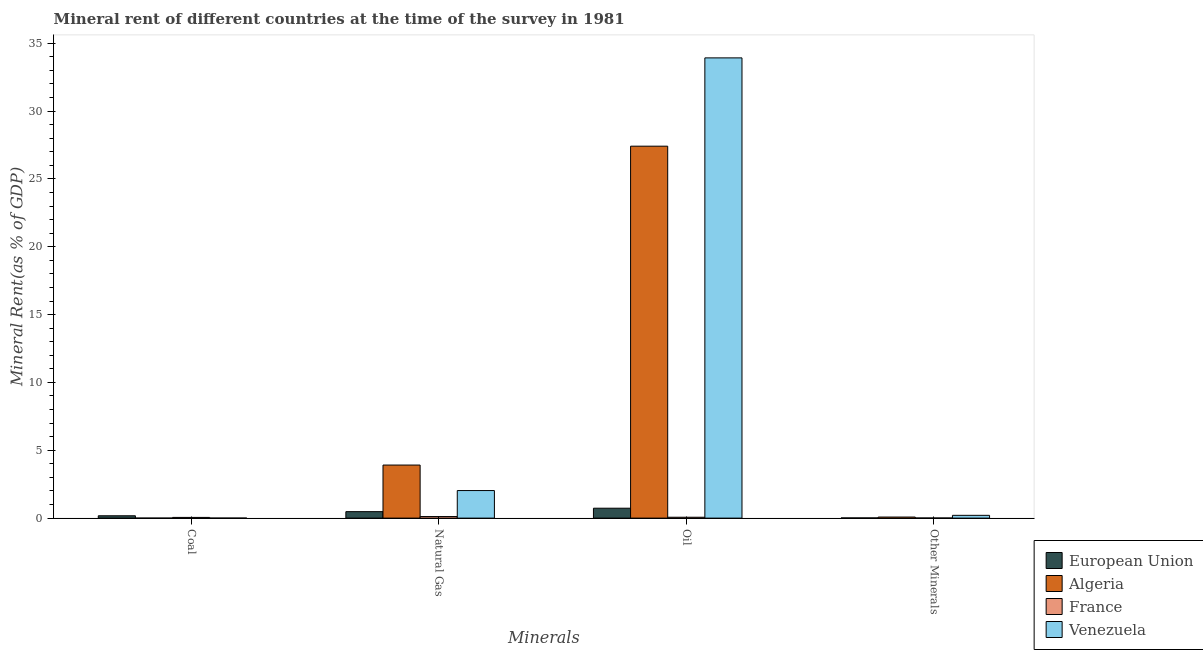How many groups of bars are there?
Ensure brevity in your answer.  4. How many bars are there on the 4th tick from the left?
Provide a succinct answer. 4. What is the label of the 1st group of bars from the left?
Keep it short and to the point. Coal. What is the  rent of other minerals in France?
Your answer should be compact. 0.01. Across all countries, what is the maximum coal rent?
Provide a succinct answer. 0.17. Across all countries, what is the minimum coal rent?
Make the answer very short. 0. In which country was the coal rent maximum?
Your response must be concise. European Union. What is the total coal rent in the graph?
Provide a succinct answer. 0.23. What is the difference between the  rent of other minerals in European Union and that in France?
Your answer should be compact. 0.01. What is the difference between the oil rent in France and the natural gas rent in Venezuela?
Your answer should be very brief. -1.97. What is the average coal rent per country?
Offer a very short reply. 0.06. What is the difference between the oil rent and  rent of other minerals in France?
Provide a short and direct response. 0.06. In how many countries, is the coal rent greater than 3 %?
Keep it short and to the point. 0. What is the ratio of the oil rent in France to that in Algeria?
Your answer should be very brief. 0. What is the difference between the highest and the second highest  rent of other minerals?
Keep it short and to the point. 0.13. What is the difference between the highest and the lowest  rent of other minerals?
Provide a succinct answer. 0.2. Is the sum of the oil rent in France and European Union greater than the maximum natural gas rent across all countries?
Keep it short and to the point. No. What does the 3rd bar from the left in Natural Gas represents?
Give a very brief answer. France. What does the 3rd bar from the right in Natural Gas represents?
Keep it short and to the point. Algeria. Is it the case that in every country, the sum of the coal rent and natural gas rent is greater than the oil rent?
Your answer should be compact. No. How many bars are there?
Your answer should be very brief. 16. Are the values on the major ticks of Y-axis written in scientific E-notation?
Give a very brief answer. No. Does the graph contain grids?
Provide a succinct answer. No. What is the title of the graph?
Make the answer very short. Mineral rent of different countries at the time of the survey in 1981. What is the label or title of the X-axis?
Offer a terse response. Minerals. What is the label or title of the Y-axis?
Offer a terse response. Mineral Rent(as % of GDP). What is the Mineral Rent(as % of GDP) in European Union in Coal?
Your answer should be very brief. 0.17. What is the Mineral Rent(as % of GDP) of Algeria in Coal?
Provide a succinct answer. 0. What is the Mineral Rent(as % of GDP) in France in Coal?
Give a very brief answer. 0.05. What is the Mineral Rent(as % of GDP) of Venezuela in Coal?
Provide a short and direct response. 0. What is the Mineral Rent(as % of GDP) in European Union in Natural Gas?
Give a very brief answer. 0.48. What is the Mineral Rent(as % of GDP) of Algeria in Natural Gas?
Keep it short and to the point. 3.91. What is the Mineral Rent(as % of GDP) in France in Natural Gas?
Keep it short and to the point. 0.12. What is the Mineral Rent(as % of GDP) in Venezuela in Natural Gas?
Your answer should be compact. 2.03. What is the Mineral Rent(as % of GDP) in European Union in Oil?
Your answer should be compact. 0.73. What is the Mineral Rent(as % of GDP) in Algeria in Oil?
Offer a terse response. 27.41. What is the Mineral Rent(as % of GDP) of France in Oil?
Provide a short and direct response. 0.06. What is the Mineral Rent(as % of GDP) in Venezuela in Oil?
Keep it short and to the point. 33.92. What is the Mineral Rent(as % of GDP) in European Union in Other Minerals?
Keep it short and to the point. 0.01. What is the Mineral Rent(as % of GDP) in Algeria in Other Minerals?
Offer a terse response. 0.08. What is the Mineral Rent(as % of GDP) in France in Other Minerals?
Ensure brevity in your answer.  0.01. What is the Mineral Rent(as % of GDP) in Venezuela in Other Minerals?
Provide a short and direct response. 0.2. Across all Minerals, what is the maximum Mineral Rent(as % of GDP) of European Union?
Give a very brief answer. 0.73. Across all Minerals, what is the maximum Mineral Rent(as % of GDP) of Algeria?
Make the answer very short. 27.41. Across all Minerals, what is the maximum Mineral Rent(as % of GDP) of France?
Offer a terse response. 0.12. Across all Minerals, what is the maximum Mineral Rent(as % of GDP) in Venezuela?
Keep it short and to the point. 33.92. Across all Minerals, what is the minimum Mineral Rent(as % of GDP) of European Union?
Your answer should be compact. 0.01. Across all Minerals, what is the minimum Mineral Rent(as % of GDP) of Algeria?
Ensure brevity in your answer.  0. Across all Minerals, what is the minimum Mineral Rent(as % of GDP) of France?
Offer a very short reply. 0.01. Across all Minerals, what is the minimum Mineral Rent(as % of GDP) in Venezuela?
Your answer should be very brief. 0. What is the total Mineral Rent(as % of GDP) in European Union in the graph?
Your answer should be very brief. 1.39. What is the total Mineral Rent(as % of GDP) of Algeria in the graph?
Provide a short and direct response. 31.4. What is the total Mineral Rent(as % of GDP) in France in the graph?
Your answer should be very brief. 0.24. What is the total Mineral Rent(as % of GDP) in Venezuela in the graph?
Ensure brevity in your answer.  36.16. What is the difference between the Mineral Rent(as % of GDP) of European Union in Coal and that in Natural Gas?
Your response must be concise. -0.3. What is the difference between the Mineral Rent(as % of GDP) of Algeria in Coal and that in Natural Gas?
Offer a very short reply. -3.91. What is the difference between the Mineral Rent(as % of GDP) of France in Coal and that in Natural Gas?
Provide a short and direct response. -0.06. What is the difference between the Mineral Rent(as % of GDP) in Venezuela in Coal and that in Natural Gas?
Your answer should be compact. -2.03. What is the difference between the Mineral Rent(as % of GDP) of European Union in Coal and that in Oil?
Keep it short and to the point. -0.56. What is the difference between the Mineral Rent(as % of GDP) of Algeria in Coal and that in Oil?
Keep it short and to the point. -27.41. What is the difference between the Mineral Rent(as % of GDP) of France in Coal and that in Oil?
Ensure brevity in your answer.  -0.01. What is the difference between the Mineral Rent(as % of GDP) in Venezuela in Coal and that in Oil?
Provide a succinct answer. -33.92. What is the difference between the Mineral Rent(as % of GDP) in European Union in Coal and that in Other Minerals?
Make the answer very short. 0.16. What is the difference between the Mineral Rent(as % of GDP) in Algeria in Coal and that in Other Minerals?
Your answer should be compact. -0.08. What is the difference between the Mineral Rent(as % of GDP) of France in Coal and that in Other Minerals?
Your response must be concise. 0.04. What is the difference between the Mineral Rent(as % of GDP) of Venezuela in Coal and that in Other Minerals?
Offer a terse response. -0.2. What is the difference between the Mineral Rent(as % of GDP) of European Union in Natural Gas and that in Oil?
Your answer should be very brief. -0.25. What is the difference between the Mineral Rent(as % of GDP) of Algeria in Natural Gas and that in Oil?
Your response must be concise. -23.5. What is the difference between the Mineral Rent(as % of GDP) of France in Natural Gas and that in Oil?
Offer a very short reply. 0.05. What is the difference between the Mineral Rent(as % of GDP) in Venezuela in Natural Gas and that in Oil?
Offer a terse response. -31.89. What is the difference between the Mineral Rent(as % of GDP) of European Union in Natural Gas and that in Other Minerals?
Your response must be concise. 0.46. What is the difference between the Mineral Rent(as % of GDP) of Algeria in Natural Gas and that in Other Minerals?
Your answer should be compact. 3.83. What is the difference between the Mineral Rent(as % of GDP) of France in Natural Gas and that in Other Minerals?
Ensure brevity in your answer.  0.11. What is the difference between the Mineral Rent(as % of GDP) of Venezuela in Natural Gas and that in Other Minerals?
Keep it short and to the point. 1.83. What is the difference between the Mineral Rent(as % of GDP) of European Union in Oil and that in Other Minerals?
Your answer should be very brief. 0.72. What is the difference between the Mineral Rent(as % of GDP) in Algeria in Oil and that in Other Minerals?
Your response must be concise. 27.33. What is the difference between the Mineral Rent(as % of GDP) in France in Oil and that in Other Minerals?
Keep it short and to the point. 0.06. What is the difference between the Mineral Rent(as % of GDP) in Venezuela in Oil and that in Other Minerals?
Keep it short and to the point. 33.71. What is the difference between the Mineral Rent(as % of GDP) in European Union in Coal and the Mineral Rent(as % of GDP) in Algeria in Natural Gas?
Offer a very short reply. -3.74. What is the difference between the Mineral Rent(as % of GDP) in European Union in Coal and the Mineral Rent(as % of GDP) in France in Natural Gas?
Ensure brevity in your answer.  0.06. What is the difference between the Mineral Rent(as % of GDP) of European Union in Coal and the Mineral Rent(as % of GDP) of Venezuela in Natural Gas?
Provide a short and direct response. -1.86. What is the difference between the Mineral Rent(as % of GDP) in Algeria in Coal and the Mineral Rent(as % of GDP) in France in Natural Gas?
Provide a short and direct response. -0.12. What is the difference between the Mineral Rent(as % of GDP) in Algeria in Coal and the Mineral Rent(as % of GDP) in Venezuela in Natural Gas?
Make the answer very short. -2.03. What is the difference between the Mineral Rent(as % of GDP) in France in Coal and the Mineral Rent(as % of GDP) in Venezuela in Natural Gas?
Your response must be concise. -1.98. What is the difference between the Mineral Rent(as % of GDP) of European Union in Coal and the Mineral Rent(as % of GDP) of Algeria in Oil?
Your answer should be compact. -27.24. What is the difference between the Mineral Rent(as % of GDP) of European Union in Coal and the Mineral Rent(as % of GDP) of France in Oil?
Offer a terse response. 0.11. What is the difference between the Mineral Rent(as % of GDP) of European Union in Coal and the Mineral Rent(as % of GDP) of Venezuela in Oil?
Provide a short and direct response. -33.75. What is the difference between the Mineral Rent(as % of GDP) in Algeria in Coal and the Mineral Rent(as % of GDP) in France in Oil?
Give a very brief answer. -0.06. What is the difference between the Mineral Rent(as % of GDP) of Algeria in Coal and the Mineral Rent(as % of GDP) of Venezuela in Oil?
Make the answer very short. -33.92. What is the difference between the Mineral Rent(as % of GDP) in France in Coal and the Mineral Rent(as % of GDP) in Venezuela in Oil?
Offer a very short reply. -33.87. What is the difference between the Mineral Rent(as % of GDP) in European Union in Coal and the Mineral Rent(as % of GDP) in Algeria in Other Minerals?
Your answer should be very brief. 0.09. What is the difference between the Mineral Rent(as % of GDP) of European Union in Coal and the Mineral Rent(as % of GDP) of France in Other Minerals?
Ensure brevity in your answer.  0.16. What is the difference between the Mineral Rent(as % of GDP) of European Union in Coal and the Mineral Rent(as % of GDP) of Venezuela in Other Minerals?
Provide a short and direct response. -0.03. What is the difference between the Mineral Rent(as % of GDP) in Algeria in Coal and the Mineral Rent(as % of GDP) in France in Other Minerals?
Provide a short and direct response. -0.01. What is the difference between the Mineral Rent(as % of GDP) in Algeria in Coal and the Mineral Rent(as % of GDP) in Venezuela in Other Minerals?
Ensure brevity in your answer.  -0.2. What is the difference between the Mineral Rent(as % of GDP) of France in Coal and the Mineral Rent(as % of GDP) of Venezuela in Other Minerals?
Provide a succinct answer. -0.15. What is the difference between the Mineral Rent(as % of GDP) in European Union in Natural Gas and the Mineral Rent(as % of GDP) in Algeria in Oil?
Keep it short and to the point. -26.93. What is the difference between the Mineral Rent(as % of GDP) in European Union in Natural Gas and the Mineral Rent(as % of GDP) in France in Oil?
Your answer should be very brief. 0.41. What is the difference between the Mineral Rent(as % of GDP) in European Union in Natural Gas and the Mineral Rent(as % of GDP) in Venezuela in Oil?
Your response must be concise. -33.44. What is the difference between the Mineral Rent(as % of GDP) in Algeria in Natural Gas and the Mineral Rent(as % of GDP) in France in Oil?
Your answer should be very brief. 3.85. What is the difference between the Mineral Rent(as % of GDP) in Algeria in Natural Gas and the Mineral Rent(as % of GDP) in Venezuela in Oil?
Provide a short and direct response. -30.01. What is the difference between the Mineral Rent(as % of GDP) in France in Natural Gas and the Mineral Rent(as % of GDP) in Venezuela in Oil?
Provide a succinct answer. -33.8. What is the difference between the Mineral Rent(as % of GDP) in European Union in Natural Gas and the Mineral Rent(as % of GDP) in Algeria in Other Minerals?
Provide a succinct answer. 0.4. What is the difference between the Mineral Rent(as % of GDP) of European Union in Natural Gas and the Mineral Rent(as % of GDP) of France in Other Minerals?
Give a very brief answer. 0.47. What is the difference between the Mineral Rent(as % of GDP) of European Union in Natural Gas and the Mineral Rent(as % of GDP) of Venezuela in Other Minerals?
Provide a short and direct response. 0.27. What is the difference between the Mineral Rent(as % of GDP) in Algeria in Natural Gas and the Mineral Rent(as % of GDP) in France in Other Minerals?
Give a very brief answer. 3.9. What is the difference between the Mineral Rent(as % of GDP) in Algeria in Natural Gas and the Mineral Rent(as % of GDP) in Venezuela in Other Minerals?
Offer a very short reply. 3.71. What is the difference between the Mineral Rent(as % of GDP) in France in Natural Gas and the Mineral Rent(as % of GDP) in Venezuela in Other Minerals?
Your answer should be very brief. -0.09. What is the difference between the Mineral Rent(as % of GDP) of European Union in Oil and the Mineral Rent(as % of GDP) of Algeria in Other Minerals?
Provide a short and direct response. 0.65. What is the difference between the Mineral Rent(as % of GDP) of European Union in Oil and the Mineral Rent(as % of GDP) of France in Other Minerals?
Offer a very short reply. 0.72. What is the difference between the Mineral Rent(as % of GDP) of European Union in Oil and the Mineral Rent(as % of GDP) of Venezuela in Other Minerals?
Offer a terse response. 0.52. What is the difference between the Mineral Rent(as % of GDP) in Algeria in Oil and the Mineral Rent(as % of GDP) in France in Other Minerals?
Give a very brief answer. 27.4. What is the difference between the Mineral Rent(as % of GDP) of Algeria in Oil and the Mineral Rent(as % of GDP) of Venezuela in Other Minerals?
Your answer should be very brief. 27.21. What is the difference between the Mineral Rent(as % of GDP) of France in Oil and the Mineral Rent(as % of GDP) of Venezuela in Other Minerals?
Your answer should be very brief. -0.14. What is the average Mineral Rent(as % of GDP) of European Union per Minerals?
Make the answer very short. 0.35. What is the average Mineral Rent(as % of GDP) of Algeria per Minerals?
Offer a very short reply. 7.85. What is the average Mineral Rent(as % of GDP) in France per Minerals?
Ensure brevity in your answer.  0.06. What is the average Mineral Rent(as % of GDP) in Venezuela per Minerals?
Your answer should be compact. 9.04. What is the difference between the Mineral Rent(as % of GDP) of European Union and Mineral Rent(as % of GDP) of Algeria in Coal?
Your answer should be compact. 0.17. What is the difference between the Mineral Rent(as % of GDP) of European Union and Mineral Rent(as % of GDP) of France in Coal?
Your answer should be very brief. 0.12. What is the difference between the Mineral Rent(as % of GDP) of European Union and Mineral Rent(as % of GDP) of Venezuela in Coal?
Ensure brevity in your answer.  0.17. What is the difference between the Mineral Rent(as % of GDP) of Algeria and Mineral Rent(as % of GDP) of France in Coal?
Offer a very short reply. -0.05. What is the difference between the Mineral Rent(as % of GDP) of Algeria and Mineral Rent(as % of GDP) of Venezuela in Coal?
Your answer should be compact. -0. What is the difference between the Mineral Rent(as % of GDP) of France and Mineral Rent(as % of GDP) of Venezuela in Coal?
Make the answer very short. 0.05. What is the difference between the Mineral Rent(as % of GDP) of European Union and Mineral Rent(as % of GDP) of Algeria in Natural Gas?
Ensure brevity in your answer.  -3.43. What is the difference between the Mineral Rent(as % of GDP) in European Union and Mineral Rent(as % of GDP) in France in Natural Gas?
Your response must be concise. 0.36. What is the difference between the Mineral Rent(as % of GDP) in European Union and Mineral Rent(as % of GDP) in Venezuela in Natural Gas?
Keep it short and to the point. -1.55. What is the difference between the Mineral Rent(as % of GDP) in Algeria and Mineral Rent(as % of GDP) in France in Natural Gas?
Give a very brief answer. 3.8. What is the difference between the Mineral Rent(as % of GDP) of Algeria and Mineral Rent(as % of GDP) of Venezuela in Natural Gas?
Your answer should be compact. 1.88. What is the difference between the Mineral Rent(as % of GDP) of France and Mineral Rent(as % of GDP) of Venezuela in Natural Gas?
Offer a terse response. -1.92. What is the difference between the Mineral Rent(as % of GDP) in European Union and Mineral Rent(as % of GDP) in Algeria in Oil?
Your response must be concise. -26.68. What is the difference between the Mineral Rent(as % of GDP) of European Union and Mineral Rent(as % of GDP) of France in Oil?
Ensure brevity in your answer.  0.66. What is the difference between the Mineral Rent(as % of GDP) in European Union and Mineral Rent(as % of GDP) in Venezuela in Oil?
Provide a succinct answer. -33.19. What is the difference between the Mineral Rent(as % of GDP) in Algeria and Mineral Rent(as % of GDP) in France in Oil?
Keep it short and to the point. 27.35. What is the difference between the Mineral Rent(as % of GDP) of Algeria and Mineral Rent(as % of GDP) of Venezuela in Oil?
Offer a very short reply. -6.51. What is the difference between the Mineral Rent(as % of GDP) in France and Mineral Rent(as % of GDP) in Venezuela in Oil?
Offer a terse response. -33.85. What is the difference between the Mineral Rent(as % of GDP) of European Union and Mineral Rent(as % of GDP) of Algeria in Other Minerals?
Your answer should be compact. -0.06. What is the difference between the Mineral Rent(as % of GDP) of European Union and Mineral Rent(as % of GDP) of France in Other Minerals?
Your answer should be compact. 0.01. What is the difference between the Mineral Rent(as % of GDP) of European Union and Mineral Rent(as % of GDP) of Venezuela in Other Minerals?
Ensure brevity in your answer.  -0.19. What is the difference between the Mineral Rent(as % of GDP) of Algeria and Mineral Rent(as % of GDP) of France in Other Minerals?
Your answer should be compact. 0.07. What is the difference between the Mineral Rent(as % of GDP) in Algeria and Mineral Rent(as % of GDP) in Venezuela in Other Minerals?
Your answer should be compact. -0.13. What is the difference between the Mineral Rent(as % of GDP) of France and Mineral Rent(as % of GDP) of Venezuela in Other Minerals?
Provide a succinct answer. -0.2. What is the ratio of the Mineral Rent(as % of GDP) in European Union in Coal to that in Natural Gas?
Your answer should be compact. 0.36. What is the ratio of the Mineral Rent(as % of GDP) of France in Coal to that in Natural Gas?
Keep it short and to the point. 0.45. What is the ratio of the Mineral Rent(as % of GDP) in Venezuela in Coal to that in Natural Gas?
Your answer should be very brief. 0. What is the ratio of the Mineral Rent(as % of GDP) of European Union in Coal to that in Oil?
Your response must be concise. 0.24. What is the ratio of the Mineral Rent(as % of GDP) of Algeria in Coal to that in Oil?
Your answer should be very brief. 0. What is the ratio of the Mineral Rent(as % of GDP) of France in Coal to that in Oil?
Offer a very short reply. 0.81. What is the ratio of the Mineral Rent(as % of GDP) in Venezuela in Coal to that in Oil?
Your answer should be compact. 0. What is the ratio of the Mineral Rent(as % of GDP) of European Union in Coal to that in Other Minerals?
Your response must be concise. 12.17. What is the ratio of the Mineral Rent(as % of GDP) in Algeria in Coal to that in Other Minerals?
Provide a succinct answer. 0. What is the ratio of the Mineral Rent(as % of GDP) in France in Coal to that in Other Minerals?
Your response must be concise. 6.2. What is the ratio of the Mineral Rent(as % of GDP) of Venezuela in Coal to that in Other Minerals?
Your response must be concise. 0.01. What is the ratio of the Mineral Rent(as % of GDP) of European Union in Natural Gas to that in Oil?
Offer a terse response. 0.65. What is the ratio of the Mineral Rent(as % of GDP) in Algeria in Natural Gas to that in Oil?
Offer a terse response. 0.14. What is the ratio of the Mineral Rent(as % of GDP) of France in Natural Gas to that in Oil?
Your response must be concise. 1.78. What is the ratio of the Mineral Rent(as % of GDP) of Venezuela in Natural Gas to that in Oil?
Provide a short and direct response. 0.06. What is the ratio of the Mineral Rent(as % of GDP) of European Union in Natural Gas to that in Other Minerals?
Provide a short and direct response. 33.6. What is the ratio of the Mineral Rent(as % of GDP) of Algeria in Natural Gas to that in Other Minerals?
Provide a succinct answer. 50.03. What is the ratio of the Mineral Rent(as % of GDP) of France in Natural Gas to that in Other Minerals?
Offer a terse response. 13.72. What is the ratio of the Mineral Rent(as % of GDP) of Venezuela in Natural Gas to that in Other Minerals?
Provide a short and direct response. 9.92. What is the ratio of the Mineral Rent(as % of GDP) in European Union in Oil to that in Other Minerals?
Your answer should be compact. 51.38. What is the ratio of the Mineral Rent(as % of GDP) in Algeria in Oil to that in Other Minerals?
Your response must be concise. 350.66. What is the ratio of the Mineral Rent(as % of GDP) in France in Oil to that in Other Minerals?
Provide a succinct answer. 7.69. What is the ratio of the Mineral Rent(as % of GDP) in Venezuela in Oil to that in Other Minerals?
Your response must be concise. 165.66. What is the difference between the highest and the second highest Mineral Rent(as % of GDP) in European Union?
Your answer should be compact. 0.25. What is the difference between the highest and the second highest Mineral Rent(as % of GDP) in Algeria?
Provide a short and direct response. 23.5. What is the difference between the highest and the second highest Mineral Rent(as % of GDP) in France?
Make the answer very short. 0.05. What is the difference between the highest and the second highest Mineral Rent(as % of GDP) of Venezuela?
Offer a very short reply. 31.89. What is the difference between the highest and the lowest Mineral Rent(as % of GDP) in European Union?
Offer a terse response. 0.72. What is the difference between the highest and the lowest Mineral Rent(as % of GDP) in Algeria?
Offer a terse response. 27.41. What is the difference between the highest and the lowest Mineral Rent(as % of GDP) in France?
Offer a very short reply. 0.11. What is the difference between the highest and the lowest Mineral Rent(as % of GDP) of Venezuela?
Offer a very short reply. 33.92. 